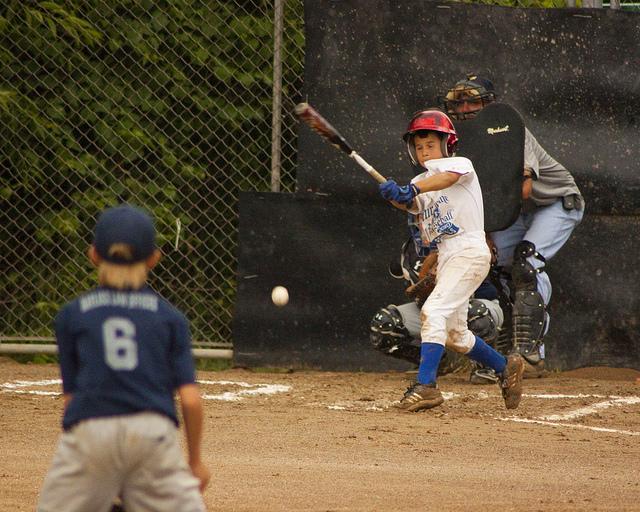What is the boy holding in his right hand?
Give a very brief answer. Bat. What color is the field?
Give a very brief answer. Brown. What sport are these guys playing?
Quick response, please. Baseball. Did he hit the ball?
Short answer required. Yes. Is the ball headed towards the batter?
Give a very brief answer. No. Is this a professional ball team?
Answer briefly. No. 